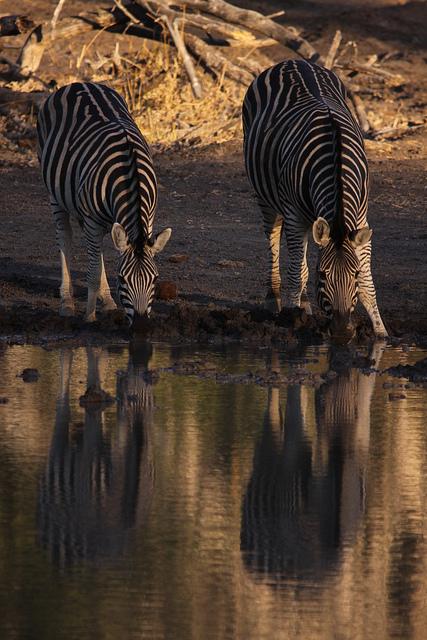What are zebras doing in the picture?
Quick response, please. Drinking. What is the zebra on the right doing?
Answer briefly. Drinking. Are they thirsty?
Write a very short answer. Yes. What are the zebras doing in this picture?
Answer briefly. Drinking. Where are the zebras?
Short answer required. By water. 